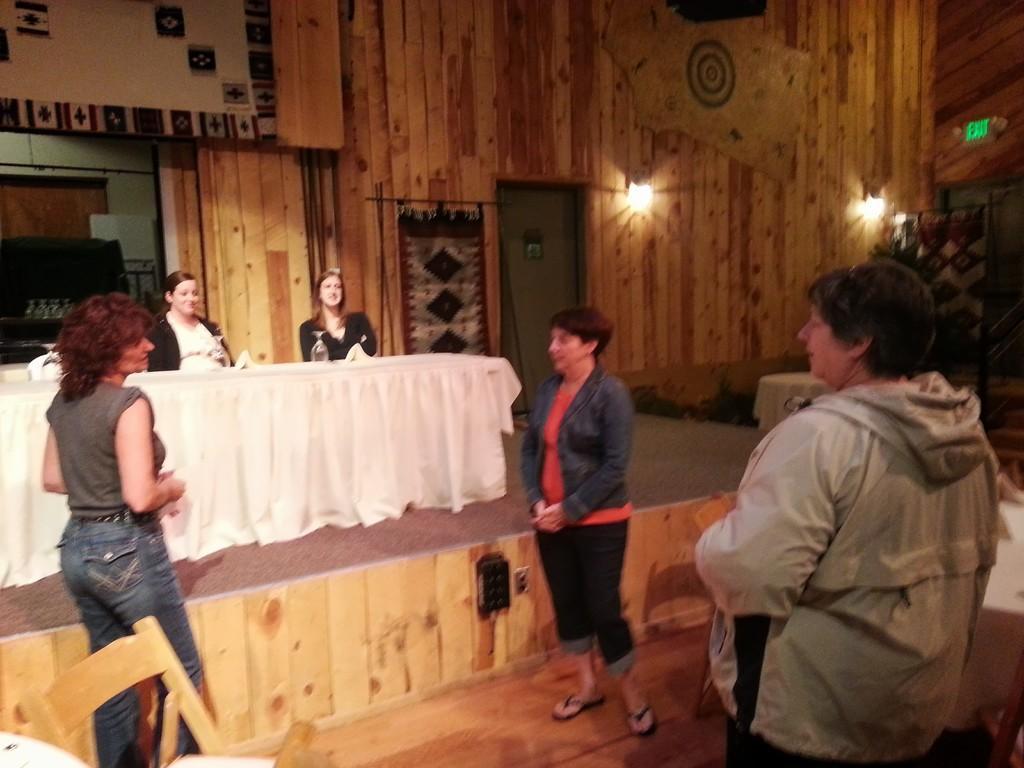Please provide a concise description of this image. In this image we can see some people standing on the ground, two women are sitting behind a table containing glasses and some clothes on it. On the left side of the image we can see chairs and some glasses placed on racks. In the background, we can see some lights on the wall, door and some tables. 